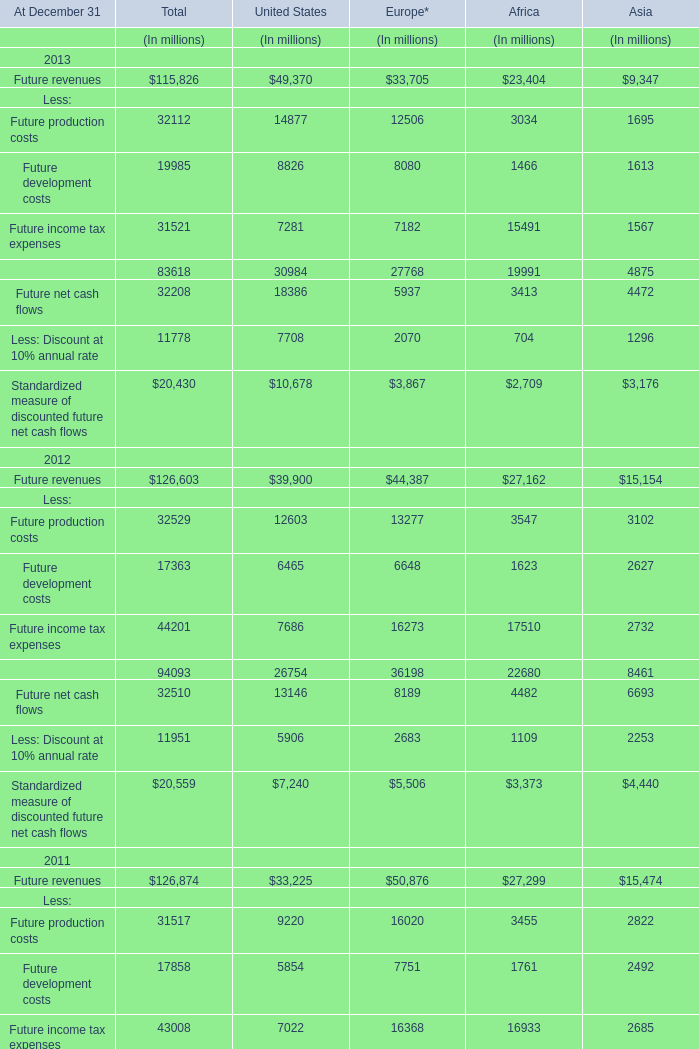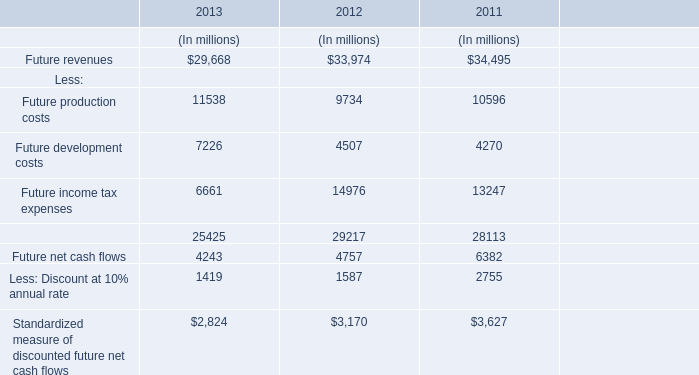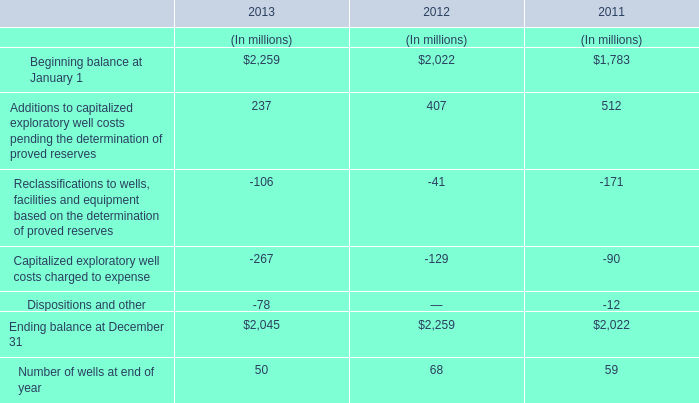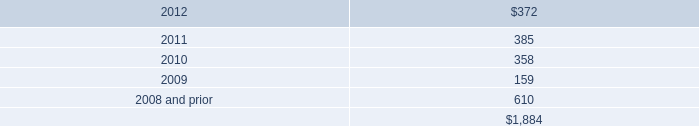What was the sum of Costs without those net cash flow smaller than 10000, in 2012? (in million) 
Computations: (9734 + 4507)
Answer: 14241.0. 